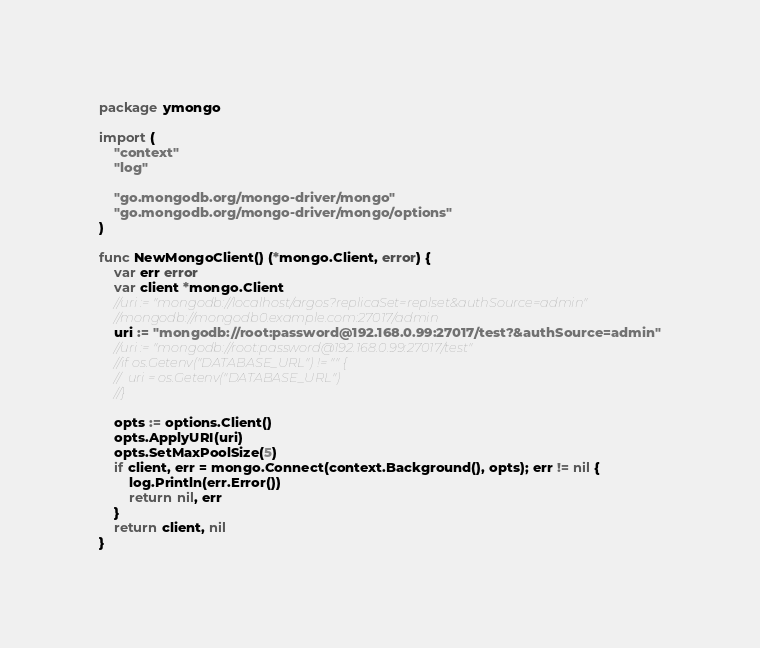<code> <loc_0><loc_0><loc_500><loc_500><_Go_>package ymongo

import (
	"context"
	"log"

	"go.mongodb.org/mongo-driver/mongo"
	"go.mongodb.org/mongo-driver/mongo/options"
)

func NewMongoClient() (*mongo.Client, error) {
	var err error
	var client *mongo.Client
	//uri := "mongodb://localhost/argos?replicaSet=replset&authSource=admin"
	//mongodb://mongodb0.example.com:27017/admin
	uri := "mongodb://root:password@192.168.0.99:27017/test?&authSource=admin"
	//uri := "mongodb://root:password@192.168.0.99:27017/test"
	//if os.Getenv("DATABASE_URL") != "" {
	//	uri = os.Getenv("DATABASE_URL")
	//}

	opts := options.Client()
	opts.ApplyURI(uri)
	opts.SetMaxPoolSize(5)
	if client, err = mongo.Connect(context.Background(), opts); err != nil {
		log.Println(err.Error())
		return nil, err
	}
	return client, nil
}
</code> 